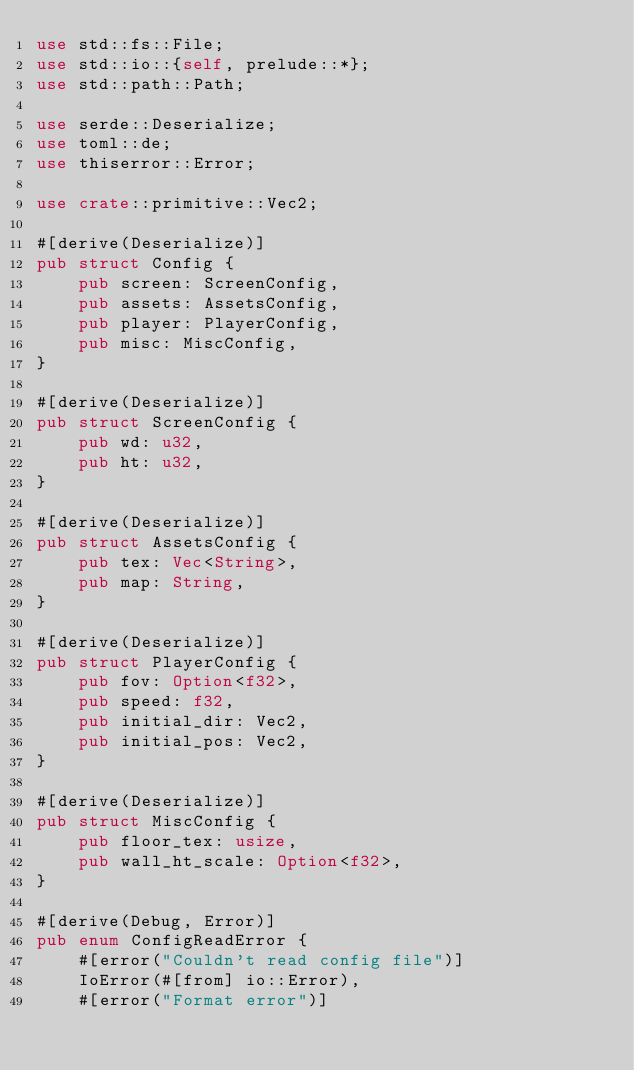<code> <loc_0><loc_0><loc_500><loc_500><_Rust_>use std::fs::File;
use std::io::{self, prelude::*};
use std::path::Path;

use serde::Deserialize;
use toml::de;
use thiserror::Error;

use crate::primitive::Vec2;

#[derive(Deserialize)]
pub struct Config {
    pub screen: ScreenConfig,
    pub assets: AssetsConfig,
    pub player: PlayerConfig,
    pub misc: MiscConfig,
}

#[derive(Deserialize)]
pub struct ScreenConfig {
    pub wd: u32,
    pub ht: u32,
}

#[derive(Deserialize)]
pub struct AssetsConfig {
    pub tex: Vec<String>,
    pub map: String,
}

#[derive(Deserialize)]
pub struct PlayerConfig {
    pub fov: Option<f32>,
    pub speed: f32,
    pub initial_dir: Vec2,
    pub initial_pos: Vec2,
}

#[derive(Deserialize)]
pub struct MiscConfig {
    pub floor_tex: usize,
    pub wall_ht_scale: Option<f32>,
}

#[derive(Debug, Error)]
pub enum ConfigReadError {
    #[error("Couldn't read config file")]
    IoError(#[from] io::Error),
    #[error("Format error")]</code> 